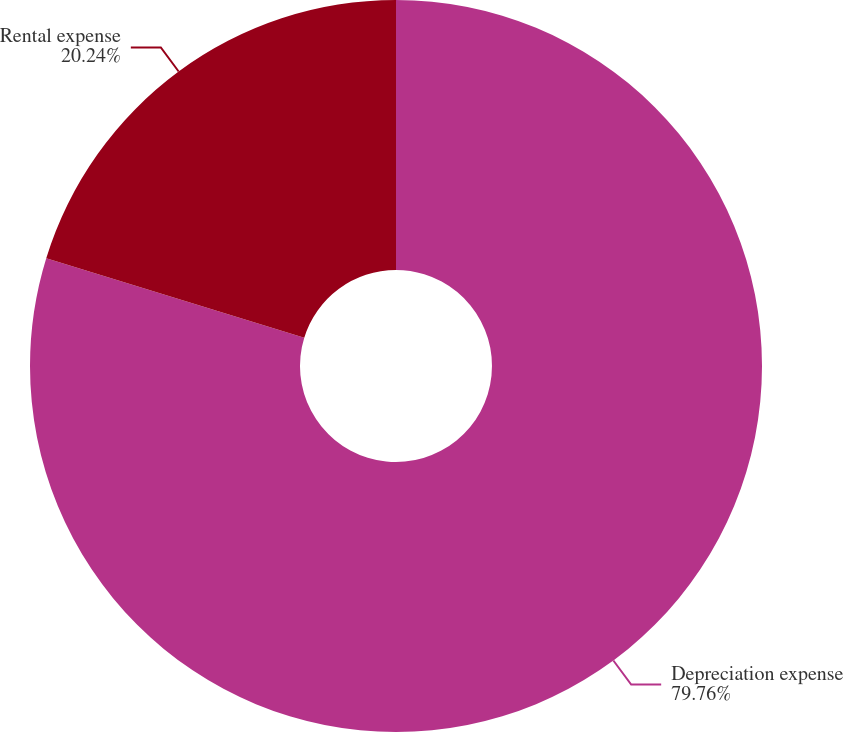<chart> <loc_0><loc_0><loc_500><loc_500><pie_chart><fcel>Depreciation expense<fcel>Rental expense<nl><fcel>79.76%<fcel>20.24%<nl></chart> 